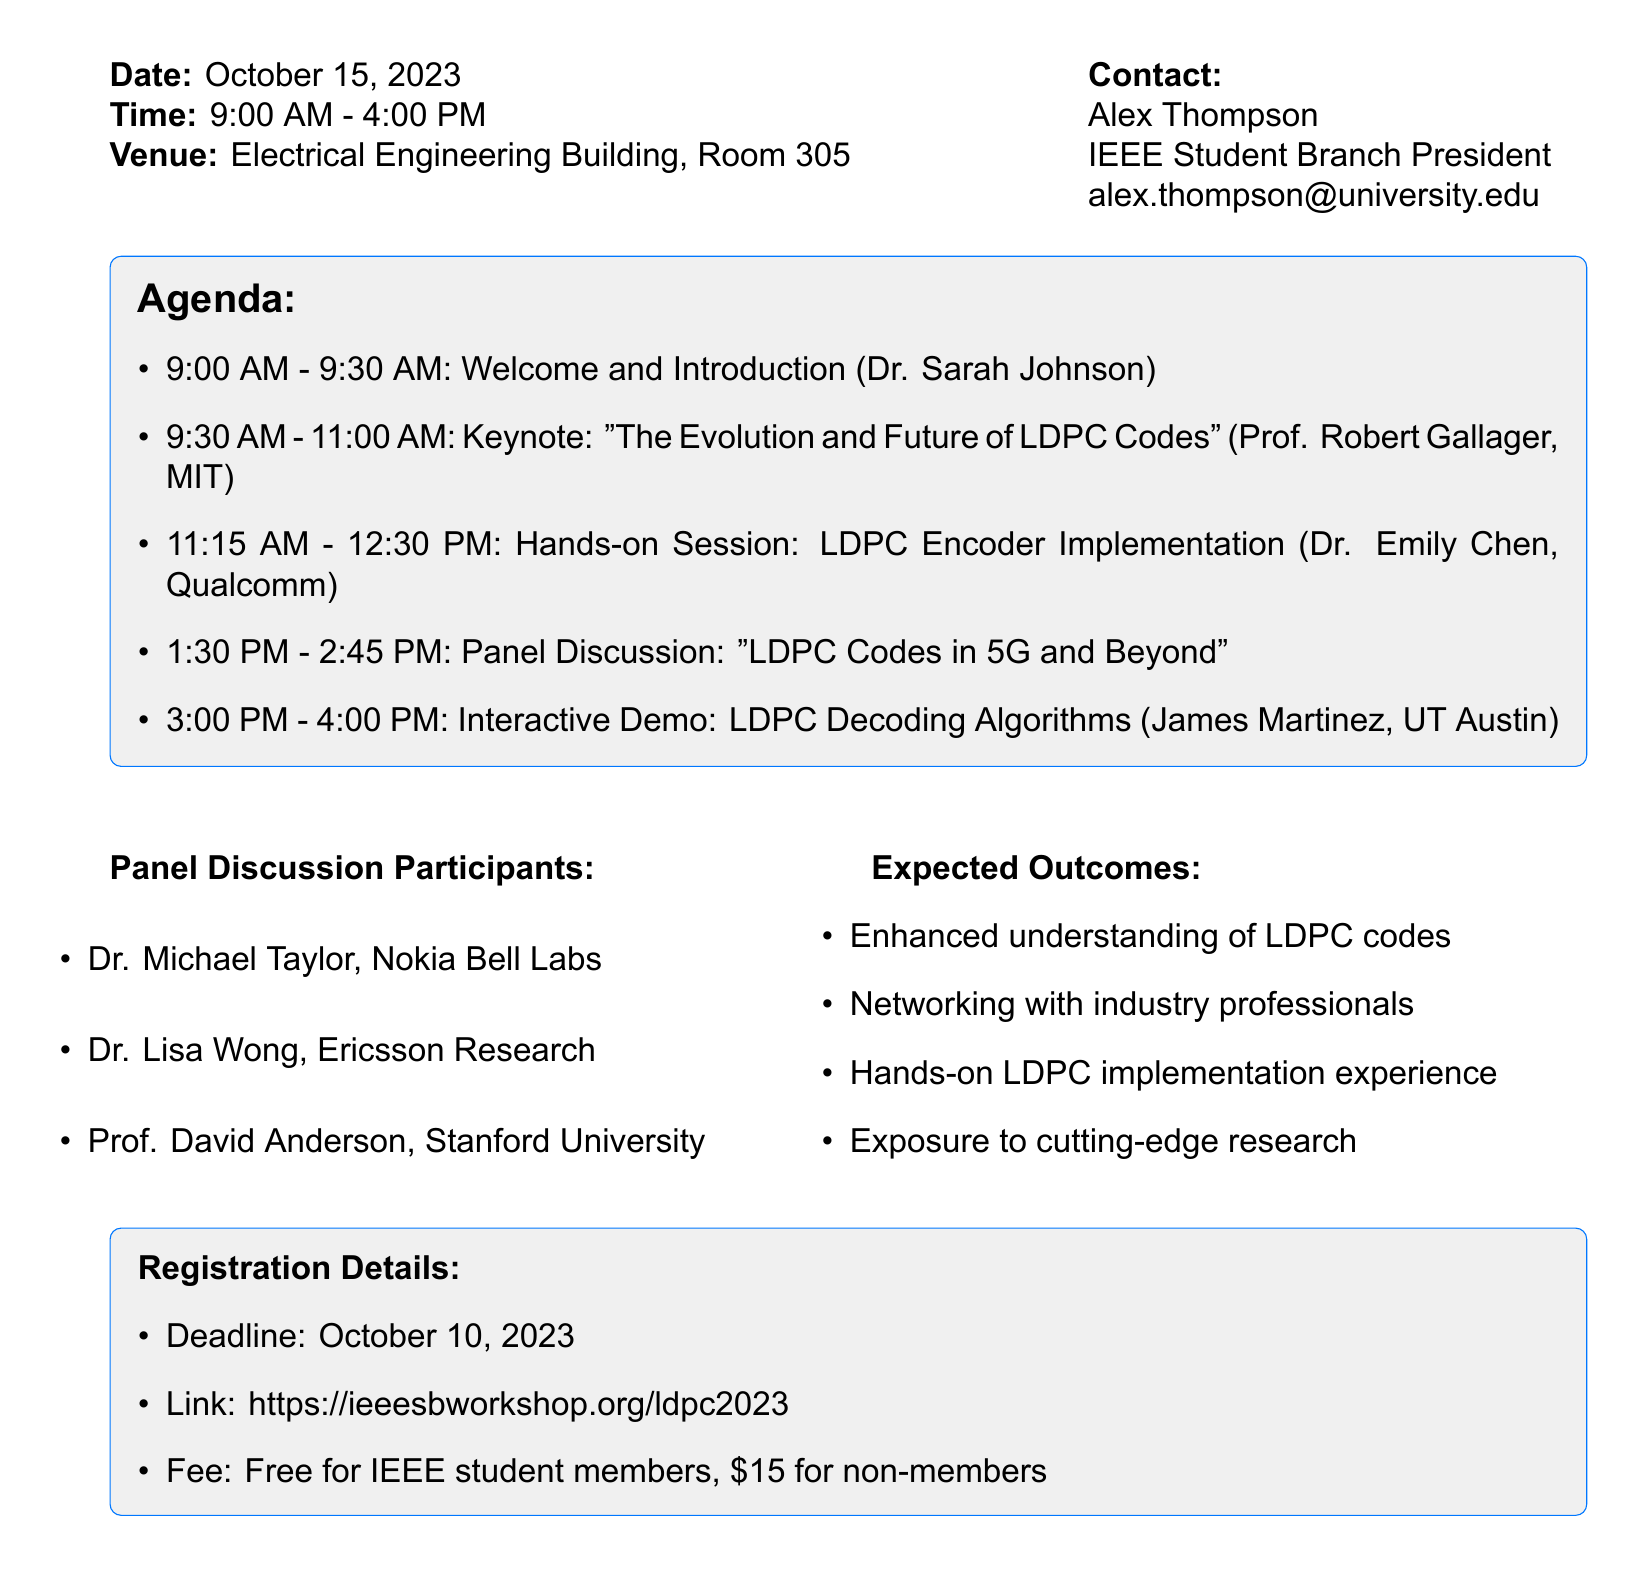What is the date of the workshop? The date is specifically mentioned at the beginning of the document.
Answer: October 15, 2023 Who is the keynote speaker? The document lists the keynote activity along with the speaker's name.
Answer: Prof. Robert Gallager What time does the interactive demo start? The time for this activity is outlined in the agenda section of the document.
Answer: 3:00 PM What is the registration deadline? This information is provided under the registration details section.
Answer: October 10, 2023 How many panelists are participating in the panel discussion? The document lists the names of the panelists involved in the discussion.
Answer: Three What is the fee for non-members? The document specifies the registration fee for different categories of participants.
Answer: $15 What type of session is led by Dr. Emily Chen? The document identifies the activity associated with Dr. Emily Chen.
Answer: Hands-on Session: LDPC Encoder Implementation What is one expected outcome of the workshop? The document lists several expected outcomes from the workshop.
Answer: Enhanced understanding of LDPC codes 